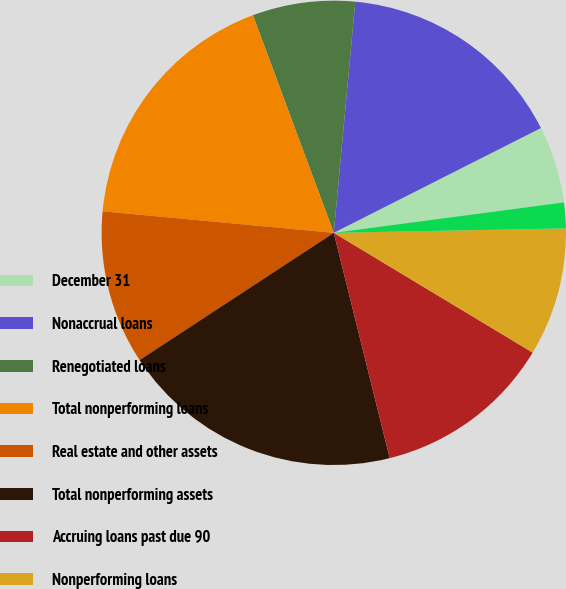Convert chart to OTSL. <chart><loc_0><loc_0><loc_500><loc_500><pie_chart><fcel>December 31<fcel>Nonaccrual loans<fcel>Renegotiated loans<fcel>Total nonperforming loans<fcel>Real estate and other assets<fcel>Total nonperforming assets<fcel>Accruing loans past due 90<fcel>Nonperforming loans<fcel>Nonperforming loans to total<nl><fcel>5.36%<fcel>16.07%<fcel>7.14%<fcel>17.86%<fcel>10.71%<fcel>19.64%<fcel>12.5%<fcel>8.93%<fcel>1.79%<nl></chart> 